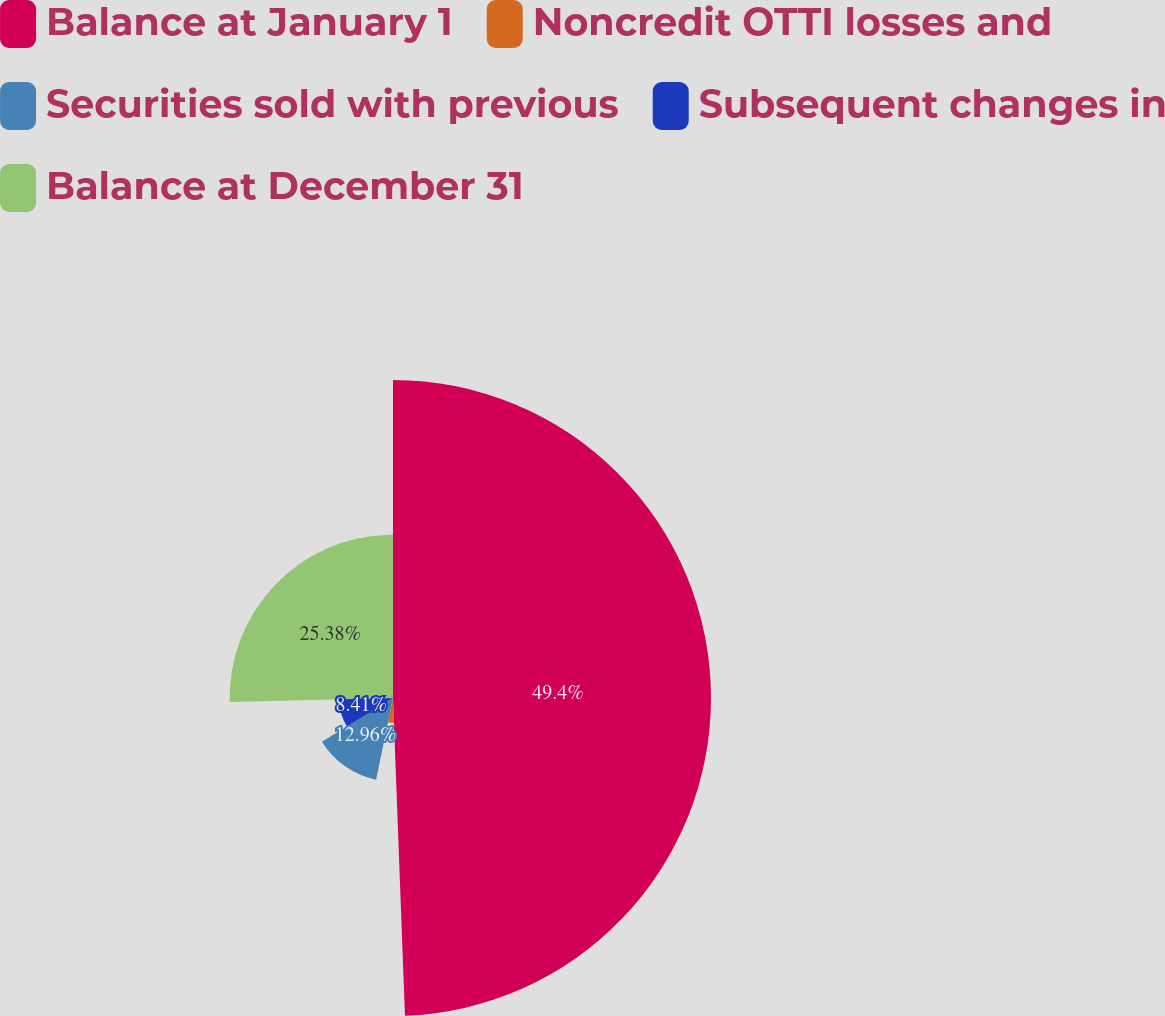Convert chart to OTSL. <chart><loc_0><loc_0><loc_500><loc_500><pie_chart><fcel>Balance at January 1<fcel>Noncredit OTTI losses and<fcel>Securities sold with previous<fcel>Subsequent changes in<fcel>Balance at December 31<nl><fcel>49.4%<fcel>3.85%<fcel>12.96%<fcel>8.41%<fcel>25.38%<nl></chart> 